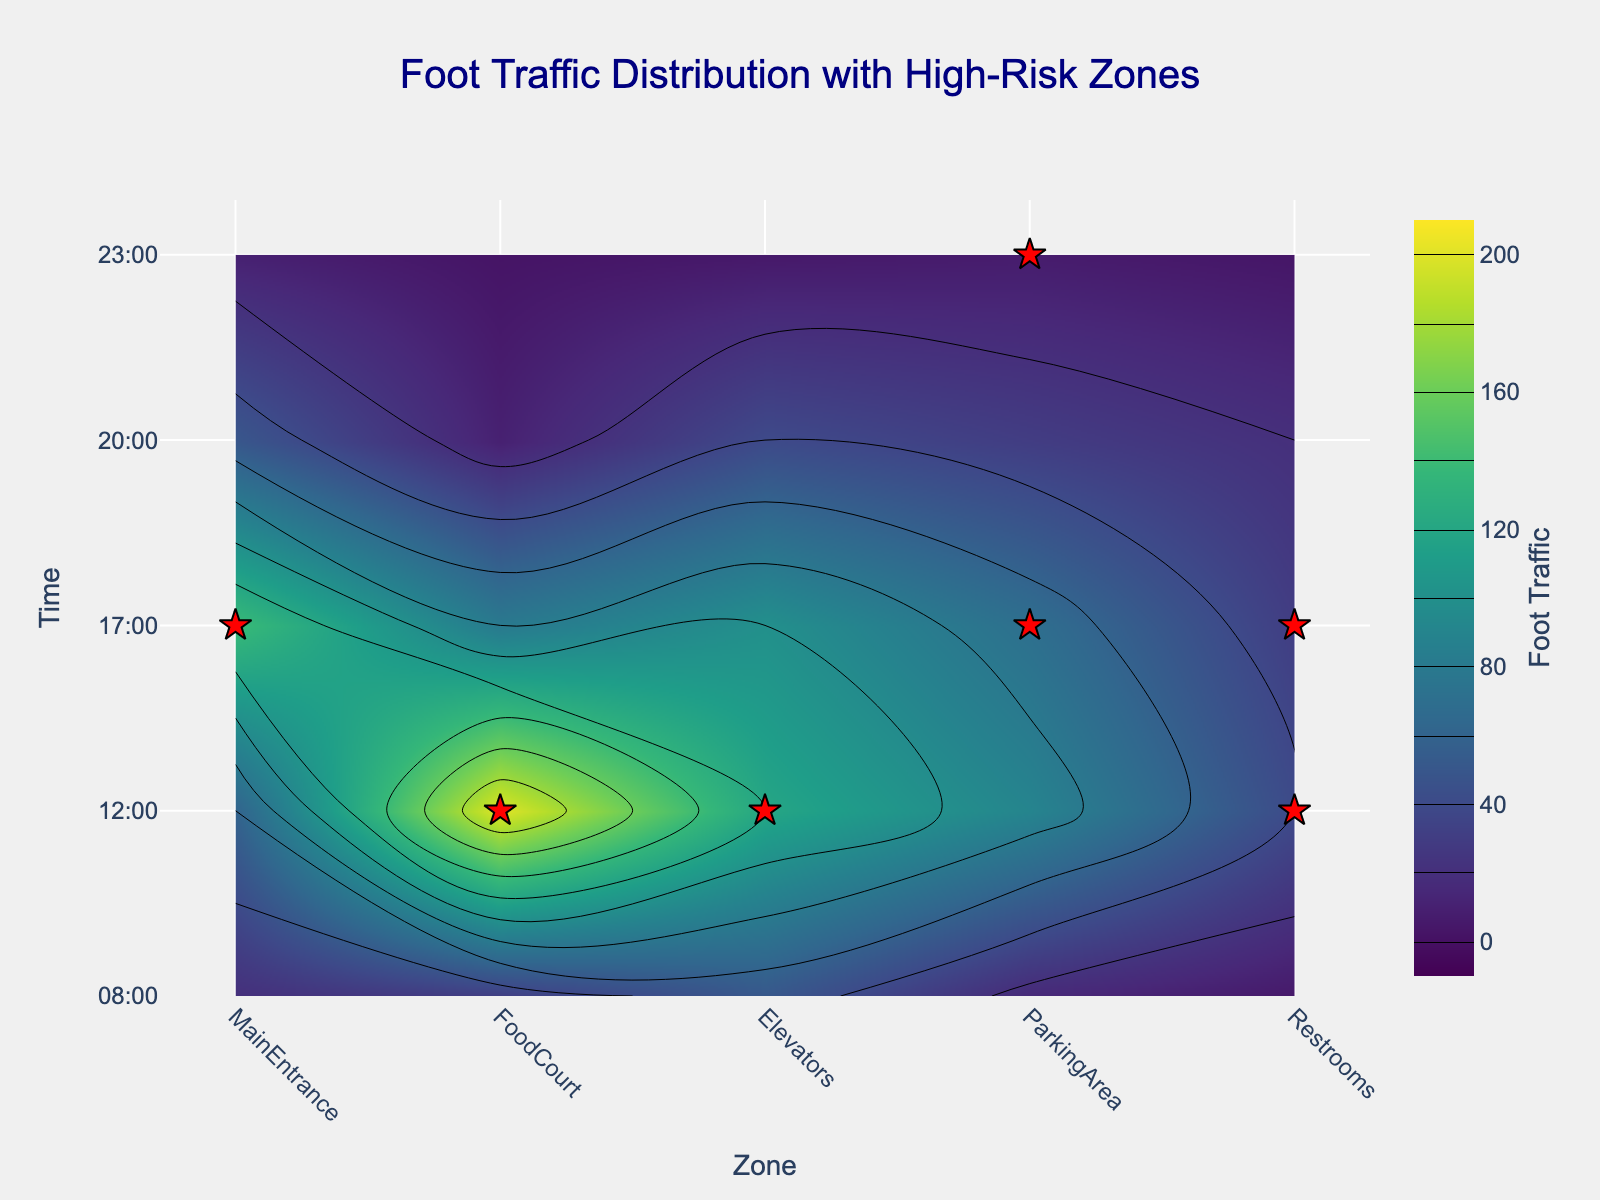what is the title of the plot? The title is prominently displayed at the top of the plot. It reads "Foot Traffic Distribution with High-Risk Zones".
Answer: Foot Traffic Distribution with High-Risk Zones what are the x and y axes labels? The x-axis label represents different zones in the commercial building, indicated as "Zone". The y-axis label represents the time of the day, indicated as "Time".
Answer: Zone, Time which zone has the highest foot traffic at 12:00? By examining the contour plot at 12:00, the darkest color that represents the highest foot traffic can be seen in the "FoodCourt" zone.
Answer: FoodCourt how many high-risk zones are there at 17:00? At 17:00, high-risk zones are marked with red stars. There are stars in "Elevators", "ParkingArea", and "Restrooms". This gives us a total of three high-risk zones.
Answer: 3 at what time does the "MainEntrance" experience the least foot traffic? By looking at the foot traffic for the "MainEntrance" across the time-axis, the lightest color, which represents the lowest foot traffic, is at 23:00.
Answer: 23:00 is there any time when the "ParkingArea" is considered high-risk? High-risk areas are marked with red stars. The "ParkingArea" is marked as high-risk at 17:00 and 23:00.
Answer: yes compare the foot traffic in the "FoodCourt" between 08:00 and 12:00 At 08:00, the contour color for the "FoodCourt" is lighter, indicating a lower foot traffic than at 12:00 where the color is much darker. Therefore, foot traffic is higher at 12:00.
Answer: higher at 12:00 what is the foot traffic in the "Elevators" at 17:00? At 17:00, the contour color on the "Elevators" zone aligns with the color bar value of 140.
Answer: 140 how many zones are marked as high-risk during the entire day? Counting all the red stars across different times and zones provides the total number of high-risk zones. There are seven high-risk zones in total.
Answer: 7 which time period has the highest concentration of high-risk zones? By examining the red stars across different times, 17:00 has the highest concentration with high-risk stars present in three zones.
Answer: 17:00 